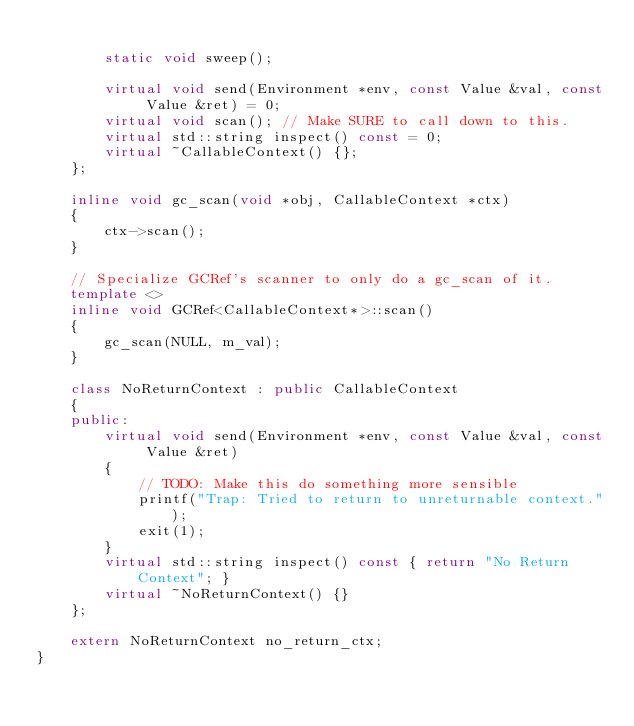Convert code to text. <code><loc_0><loc_0><loc_500><loc_500><_C++_>
		static void sweep();

		virtual void send(Environment *env, const Value &val, const Value &ret) = 0;
		virtual void scan(); // Make SURE to call down to this.
		virtual std::string inspect() const = 0;
		virtual ~CallableContext() {};
	};

	inline void gc_scan(void *obj, CallableContext *ctx)
	{
		ctx->scan();
	}

	// Specialize GCRef's scanner to only do a gc_scan of it.
	template <>
	inline void GCRef<CallableContext*>::scan()
	{
		gc_scan(NULL, m_val);
	}

	class NoReturnContext : public CallableContext
	{
	public:
		virtual void send(Environment *env, const Value &val, const Value &ret)
		{
			// TODO: Make this do something more sensible
			printf("Trap: Tried to return to unreturnable context.");
			exit(1);
		}
		virtual std::string inspect() const { return "No Return Context"; }
		virtual ~NoReturnContext() {}
	};

	extern NoReturnContext no_return_ctx;
}
</code> 